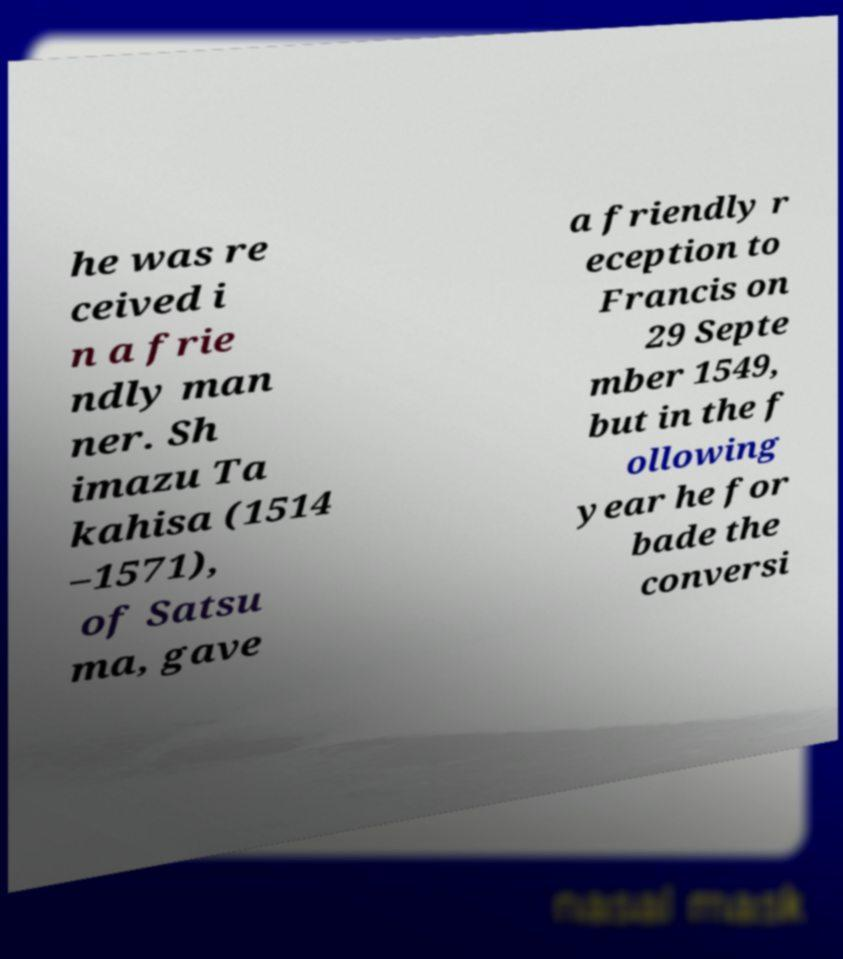Could you extract and type out the text from this image? he was re ceived i n a frie ndly man ner. Sh imazu Ta kahisa (1514 –1571), of Satsu ma, gave a friendly r eception to Francis on 29 Septe mber 1549, but in the f ollowing year he for bade the conversi 